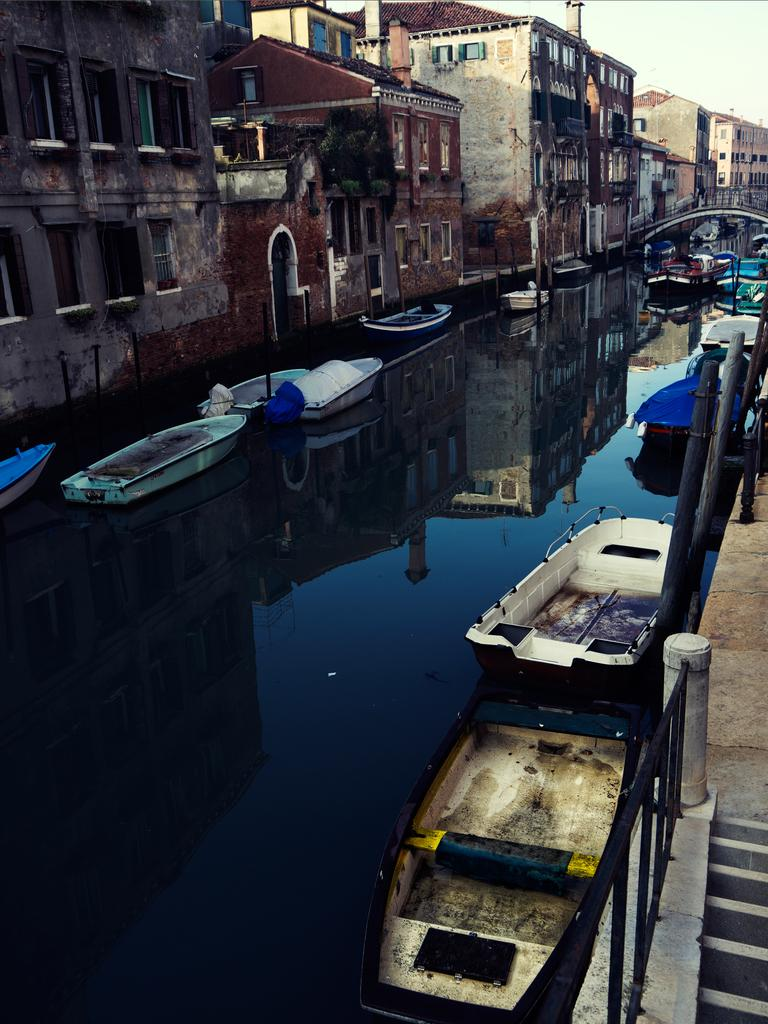What is on the water in the image? There are boats on the water in the image. What type of structures can be seen in the image? There are buildings in the image. What architectural feature is present in the image? There are windows in the image. What type of vegetation is visible in the image? There are plants in the image. What safety feature is present in the image? There are railings in the image. What is visible above the structures and vegetation in the image? The sky is visible in the image. What type of rail can be seen in the image? There is no rail present in the image; there are only railings. What type of hat is the plant wearing in the image? There are no hats present in the image, as plants do not wear hats. 